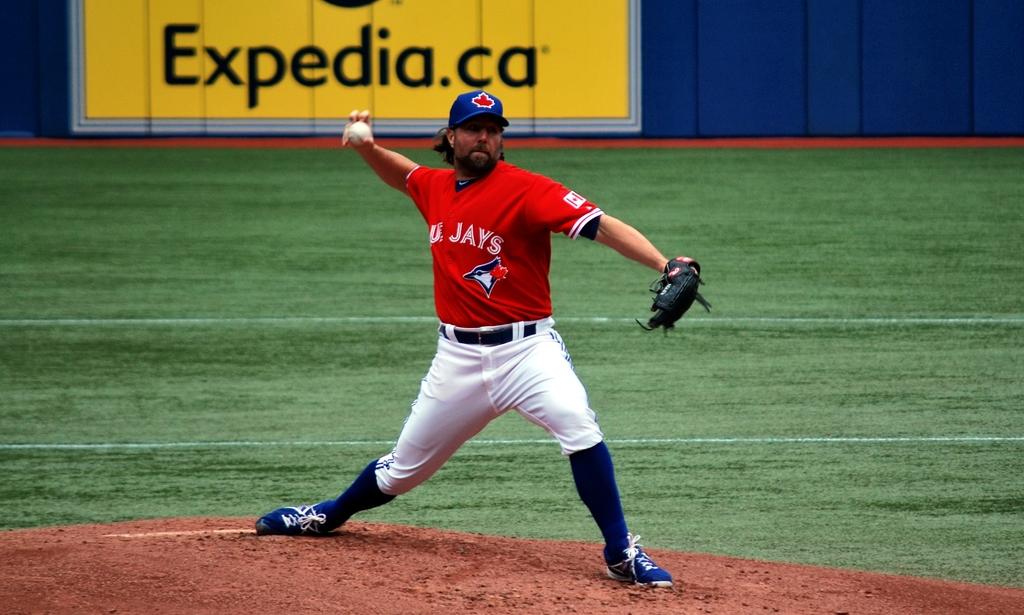What team does this pitcher play for?
Provide a succinct answer. Blue jays. What website is mentioned behind the player?
Provide a succinct answer. Expedia.ca. 